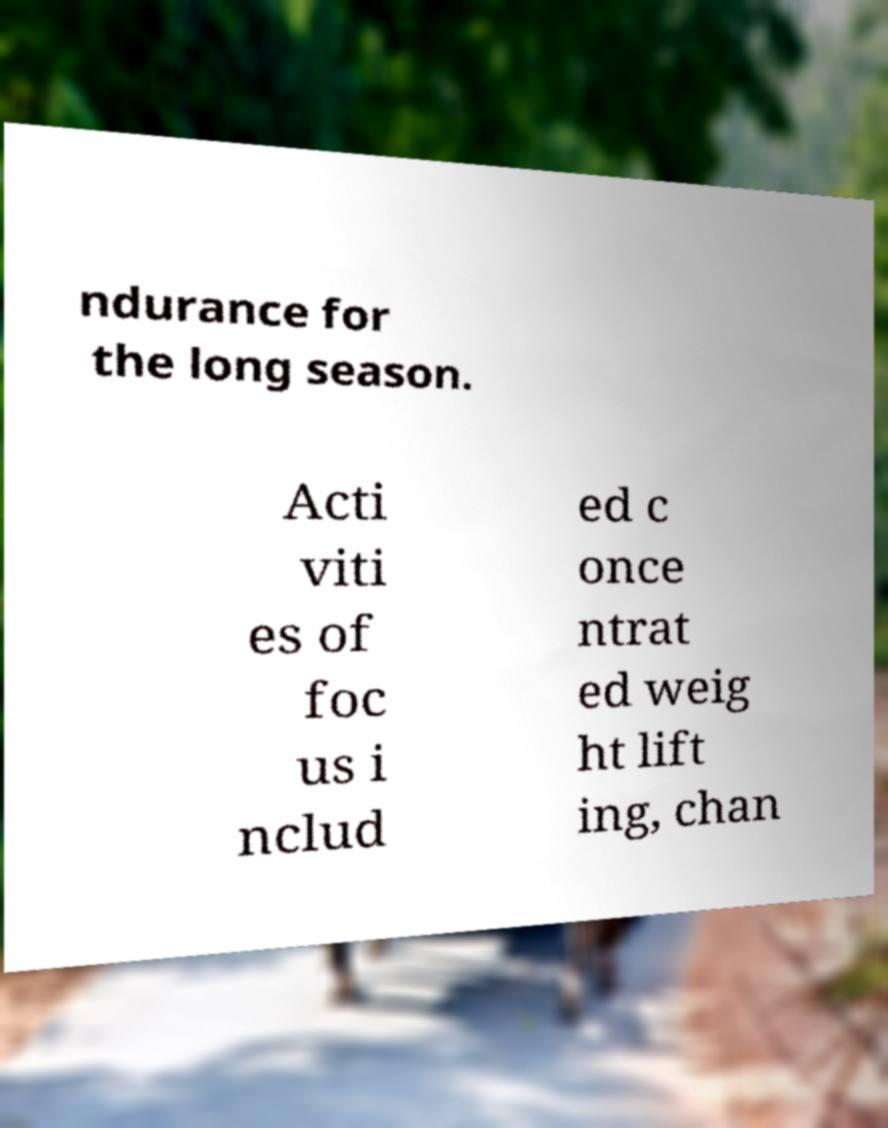Could you extract and type out the text from this image? ndurance for the long season. Acti viti es of foc us i nclud ed c once ntrat ed weig ht lift ing, chan 